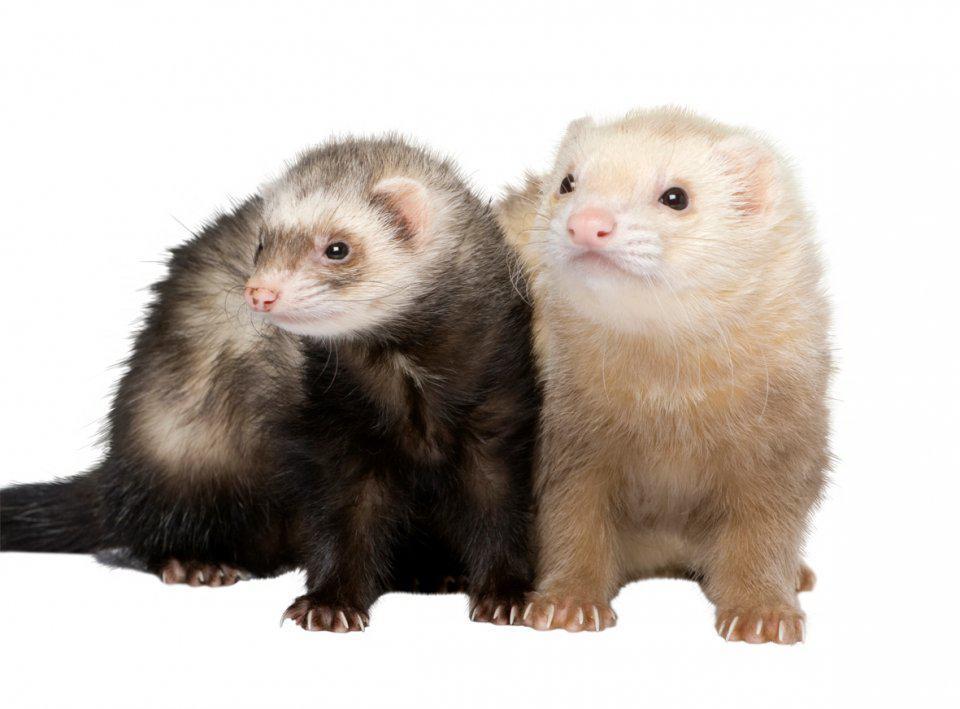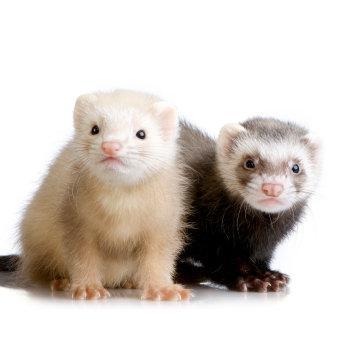The first image is the image on the left, the second image is the image on the right. Analyze the images presented: Is the assertion "Each image contains a pair of ferrets that are brown and light colored and grouped together." valid? Answer yes or no. Yes. 